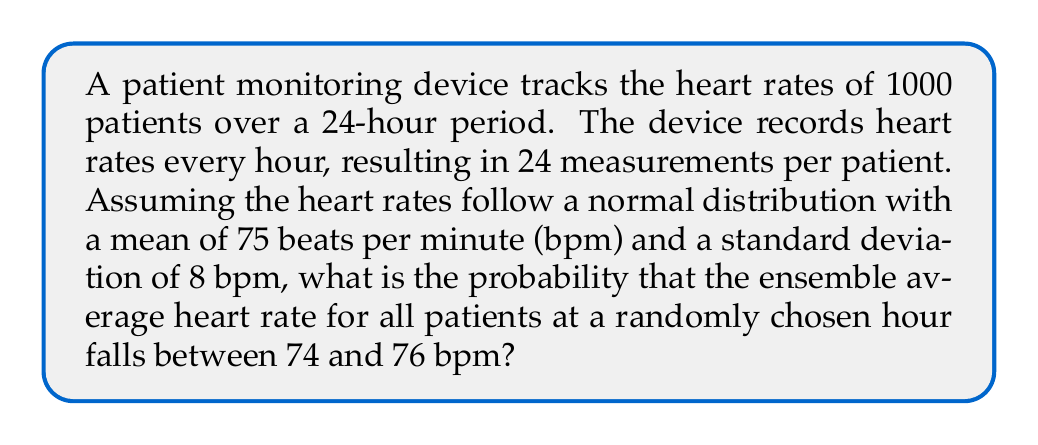Show me your answer to this math problem. To solve this problem, we need to use the concept of ensemble averages from statistical mechanics and apply it to patient outcomes. Let's break it down step-by-step:

1) First, we need to understand what the ensemble average represents in this context. It's the average heart rate of all 1000 patients at a given hour.

2) The Central Limit Theorem states that the distribution of sample means (in this case, our ensemble averages) will be approximately normal, regardless of the underlying distribution, when the sample size is large enough (generally n > 30).

3) We have 1000 patients, which is certainly large enough for the Central Limit Theorem to apply.

4) The mean of the sampling distribution of the mean (ensemble average) will be the same as the population mean: $\mu_{ensemble} = 75$ bpm

5) The standard error of the mean (standard deviation of the sampling distribution) is given by:

   $$\sigma_{ensemble} = \frac{\sigma}{\sqrt{n}} = \frac{8}{\sqrt{1000}} = 0.253$$

6) Now, we need to calculate the z-scores for our range:

   $$z_{lower} = \frac{74 - 75}{0.253} = -3.95$$
   $$z_{upper} = \frac{76 - 75}{0.253} = 3.95$$

7) The probability we're looking for is the area under the standard normal curve between these z-scores. We can use the standard normal cumulative distribution function (often denoted as Φ) to find this:

   $$P(74 < \text{ensemble average} < 76) = \Phi(3.95) - \Phi(-3.95)$$

8) Using a standard normal table or calculator:

   $$\Phi(3.95) \approx 0.99996$$
   $$\Phi(-3.95) \approx 0.00004$$

9) Therefore, the probability is:

   $$0.99996 - 0.00004 = 0.99992$$
Answer: 0.99992 